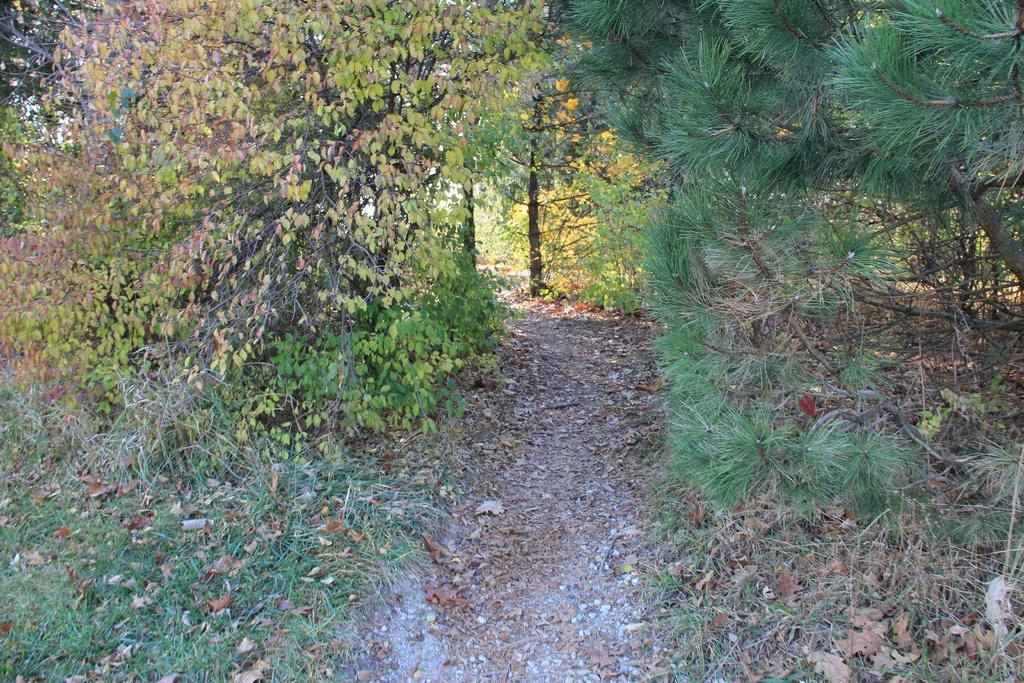What type of vegetation is visible in the image? There is a group of trees in the image. What type of ground cover is present in the image? There is grass in the image. Is there any indication of a designated walking area in the image? Yes, there is a pathway in the image. What can be seen on the ground among the grass and trees? Dried leaves are present on the ground in the image. What type of music can be heard playing in the background of the image? There is no music present in the image, as it is a still photograph. 